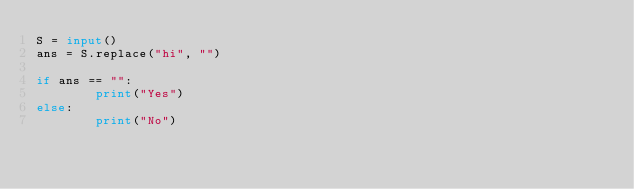<code> <loc_0><loc_0><loc_500><loc_500><_Python_>S = input()
ans = S.replace("hi", "")

if ans == "":
        print("Yes")
else:
        print("No")
</code> 